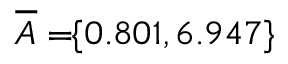<formula> <loc_0><loc_0><loc_500><loc_500>\, \overline { A } = \, \{ 0 . 8 0 1 , 6 . 9 4 7 \} \,</formula> 